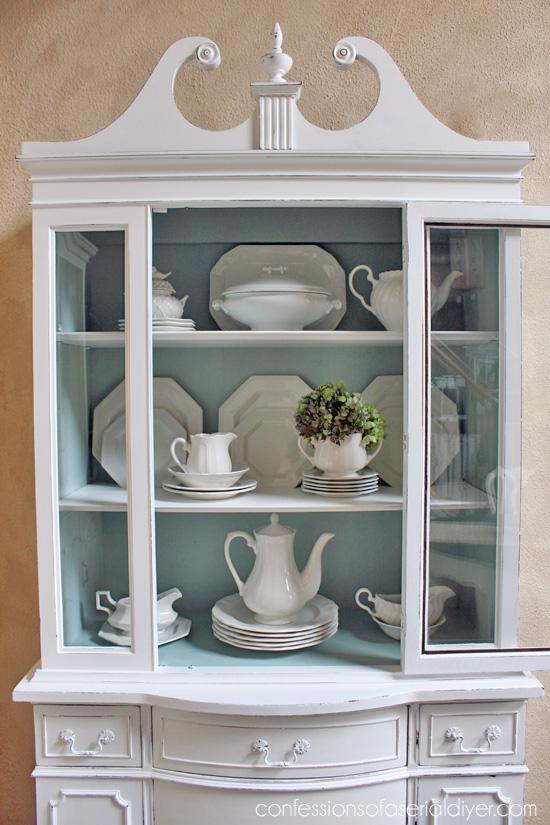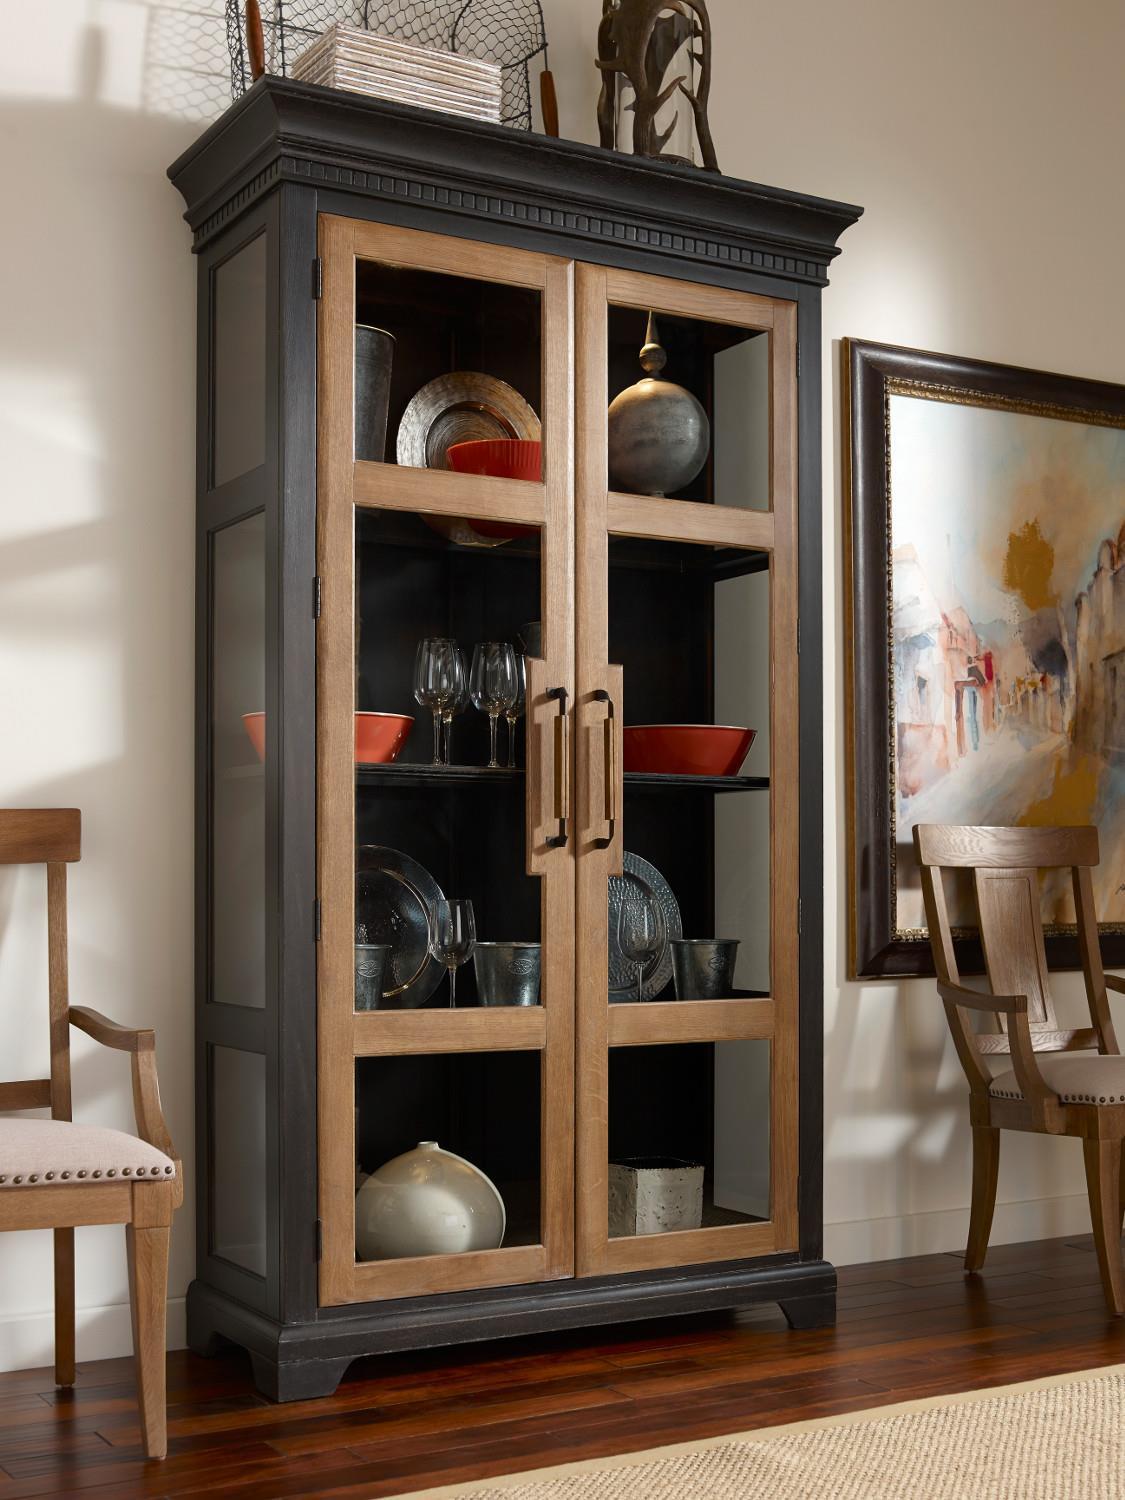The first image is the image on the left, the second image is the image on the right. Given the left and right images, does the statement "There are objects in the white cabinet in the image on the left." hold true? Answer yes or no. Yes. The first image is the image on the left, the second image is the image on the right. Examine the images to the left and right. Is the description "The right image contains a chair." accurate? Answer yes or no. Yes. 